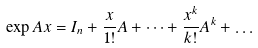<formula> <loc_0><loc_0><loc_500><loc_500>\exp A x = I _ { n } + \frac { x } { 1 ! } A + \dots + \frac { x ^ { k } } { k ! } A ^ { k } + \dots</formula> 